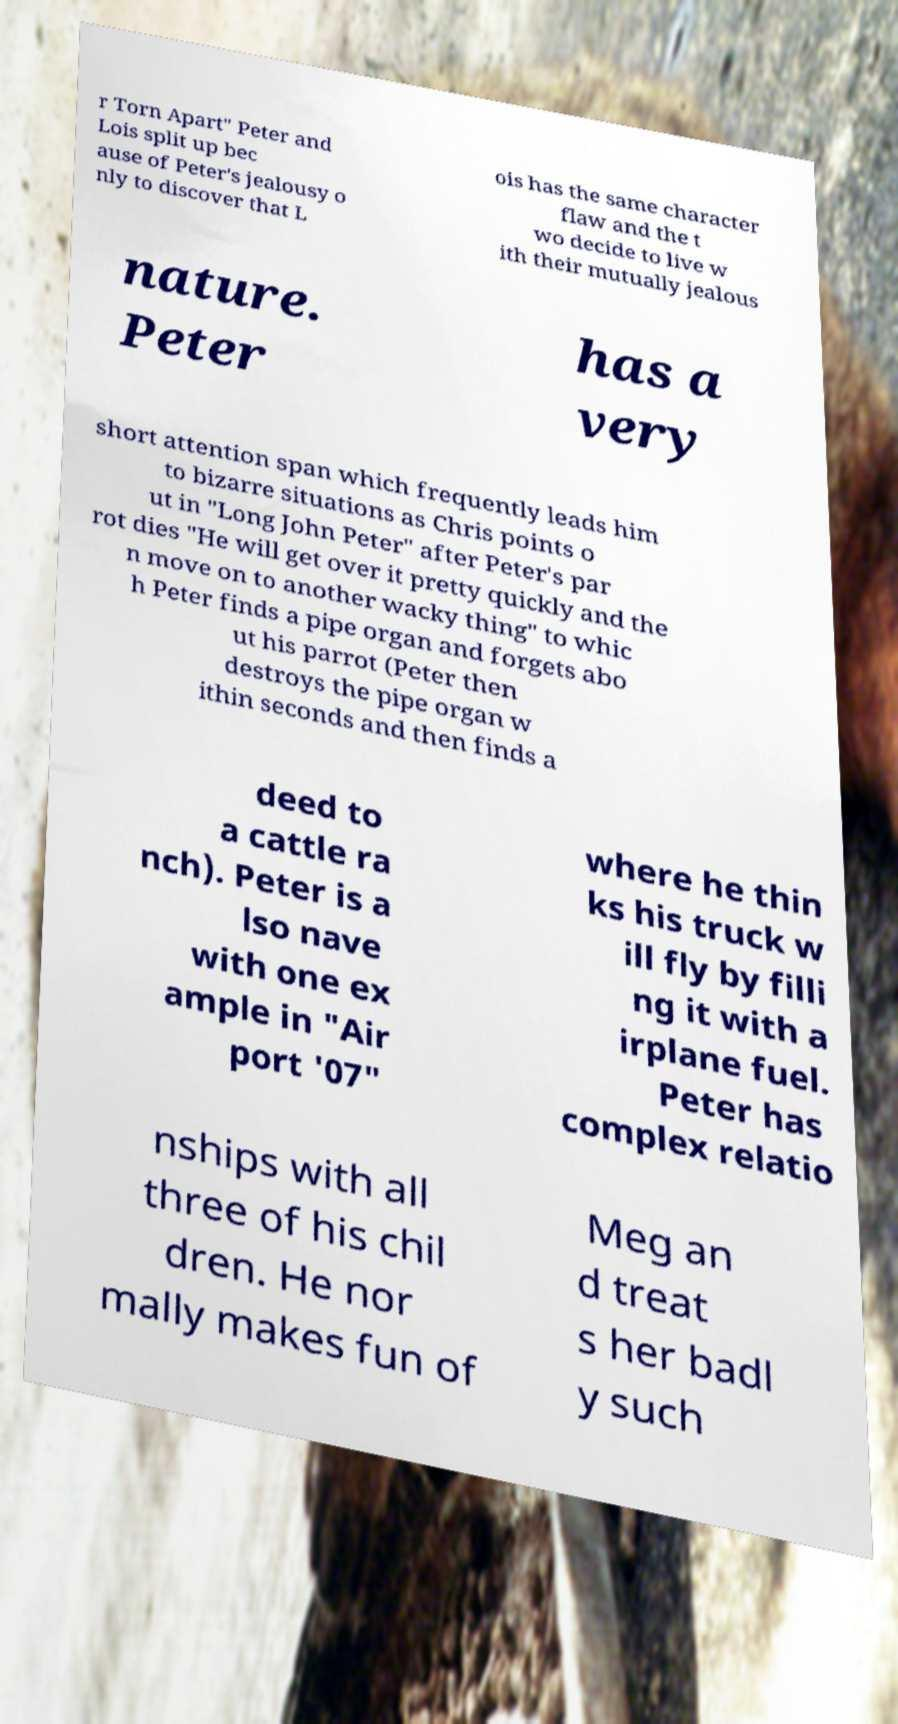For documentation purposes, I need the text within this image transcribed. Could you provide that? r Torn Apart" Peter and Lois split up bec ause of Peter's jealousy o nly to discover that L ois has the same character flaw and the t wo decide to live w ith their mutually jealous nature. Peter has a very short attention span which frequently leads him to bizarre situations as Chris points o ut in "Long John Peter" after Peter's par rot dies "He will get over it pretty quickly and the n move on to another wacky thing" to whic h Peter finds a pipe organ and forgets abo ut his parrot (Peter then destroys the pipe organ w ithin seconds and then finds a deed to a cattle ra nch). Peter is a lso nave with one ex ample in "Air port '07" where he thin ks his truck w ill fly by filli ng it with a irplane fuel. Peter has complex relatio nships with all three of his chil dren. He nor mally makes fun of Meg an d treat s her badl y such 